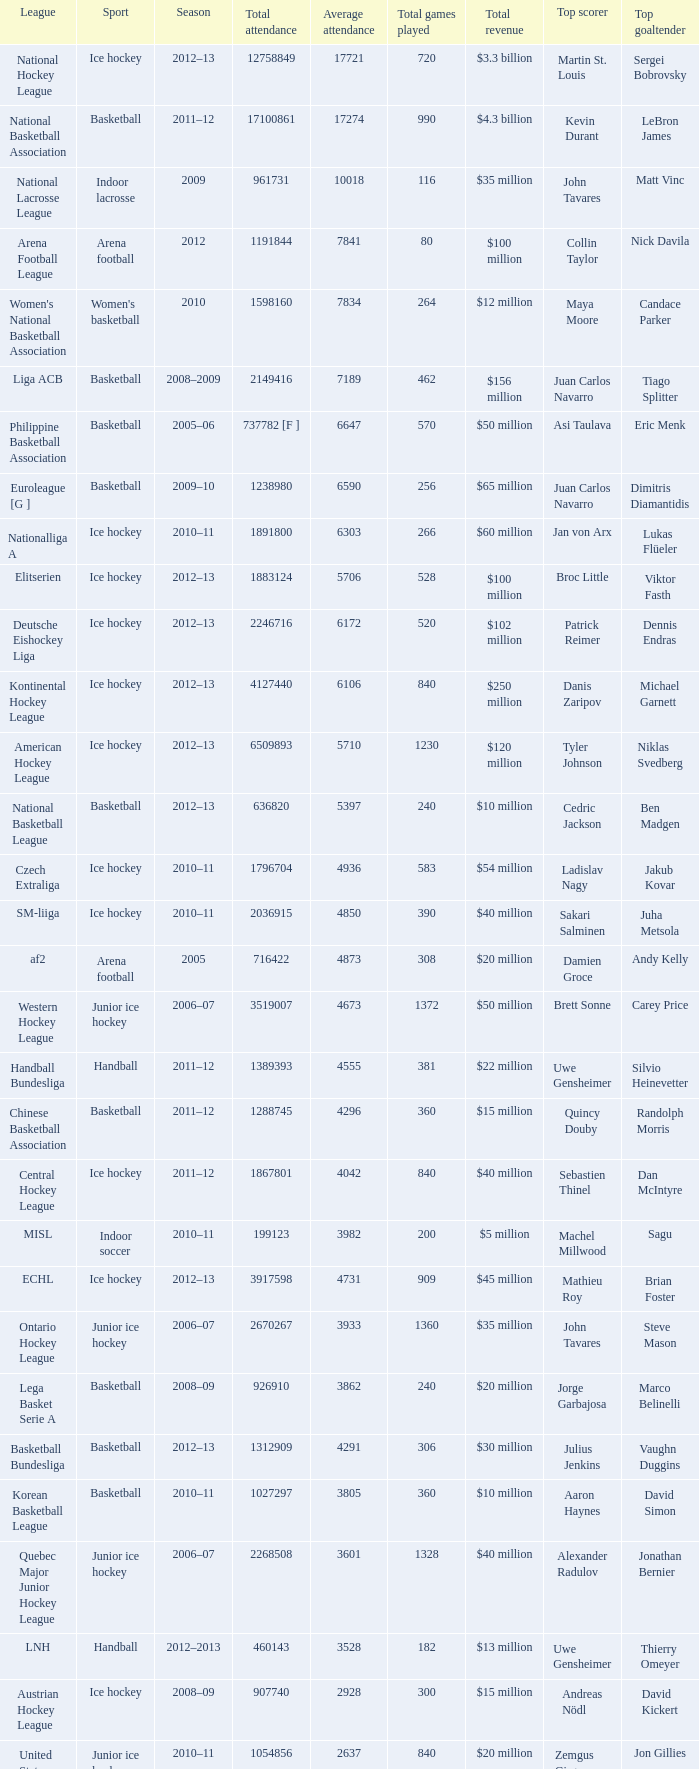What's the average attendance of the league with a total attendance of 2268508? 3601.0. 